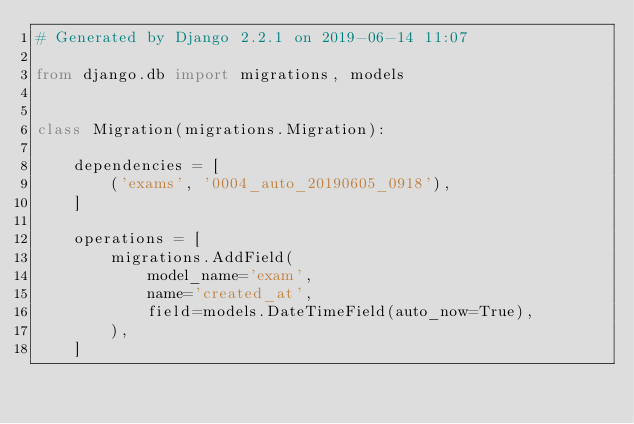<code> <loc_0><loc_0><loc_500><loc_500><_Python_># Generated by Django 2.2.1 on 2019-06-14 11:07

from django.db import migrations, models


class Migration(migrations.Migration):

    dependencies = [
        ('exams', '0004_auto_20190605_0918'),
    ]

    operations = [
        migrations.AddField(
            model_name='exam',
            name='created_at',
            field=models.DateTimeField(auto_now=True),
        ),
    ]
</code> 